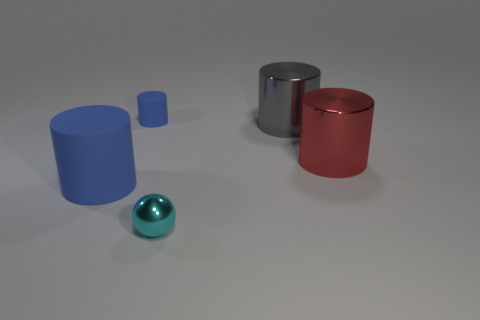Does the tiny cylinder have the same color as the large matte cylinder?
Offer a terse response. Yes. There is a large red metallic cylinder; what number of metal things are behind it?
Give a very brief answer. 1. Is the number of tiny blue rubber objects in front of the gray thing the same as the number of big matte things?
Keep it short and to the point. No. What number of objects are tiny shiny objects or large gray metal cylinders?
Offer a very short reply. 2. Are there any other things that have the same shape as the tiny cyan shiny object?
Provide a succinct answer. No. The tiny thing that is behind the big cylinder that is left of the small cyan ball is what shape?
Give a very brief answer. Cylinder. There is a red thing that is the same material as the gray object; what is its shape?
Provide a succinct answer. Cylinder. There is a object to the left of the matte cylinder to the right of the big blue matte thing; how big is it?
Offer a terse response. Large. What is the shape of the gray metal object?
Ensure brevity in your answer.  Cylinder. How many tiny things are matte cylinders or gray spheres?
Your answer should be compact. 1. 